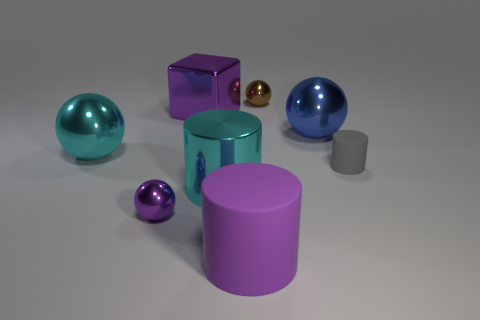Subtract all blocks. How many objects are left? 7 Add 1 cyan metallic spheres. How many objects exist? 9 Subtract all blue spheres. How many spheres are left? 3 Subtract all cyan metallic spheres. How many spheres are left? 3 Subtract 1 blue spheres. How many objects are left? 7 Subtract 2 balls. How many balls are left? 2 Subtract all green blocks. Subtract all brown balls. How many blocks are left? 1 Subtract all green cylinders. How many blue spheres are left? 1 Subtract all blue balls. Subtract all large blue matte objects. How many objects are left? 7 Add 1 brown balls. How many brown balls are left? 2 